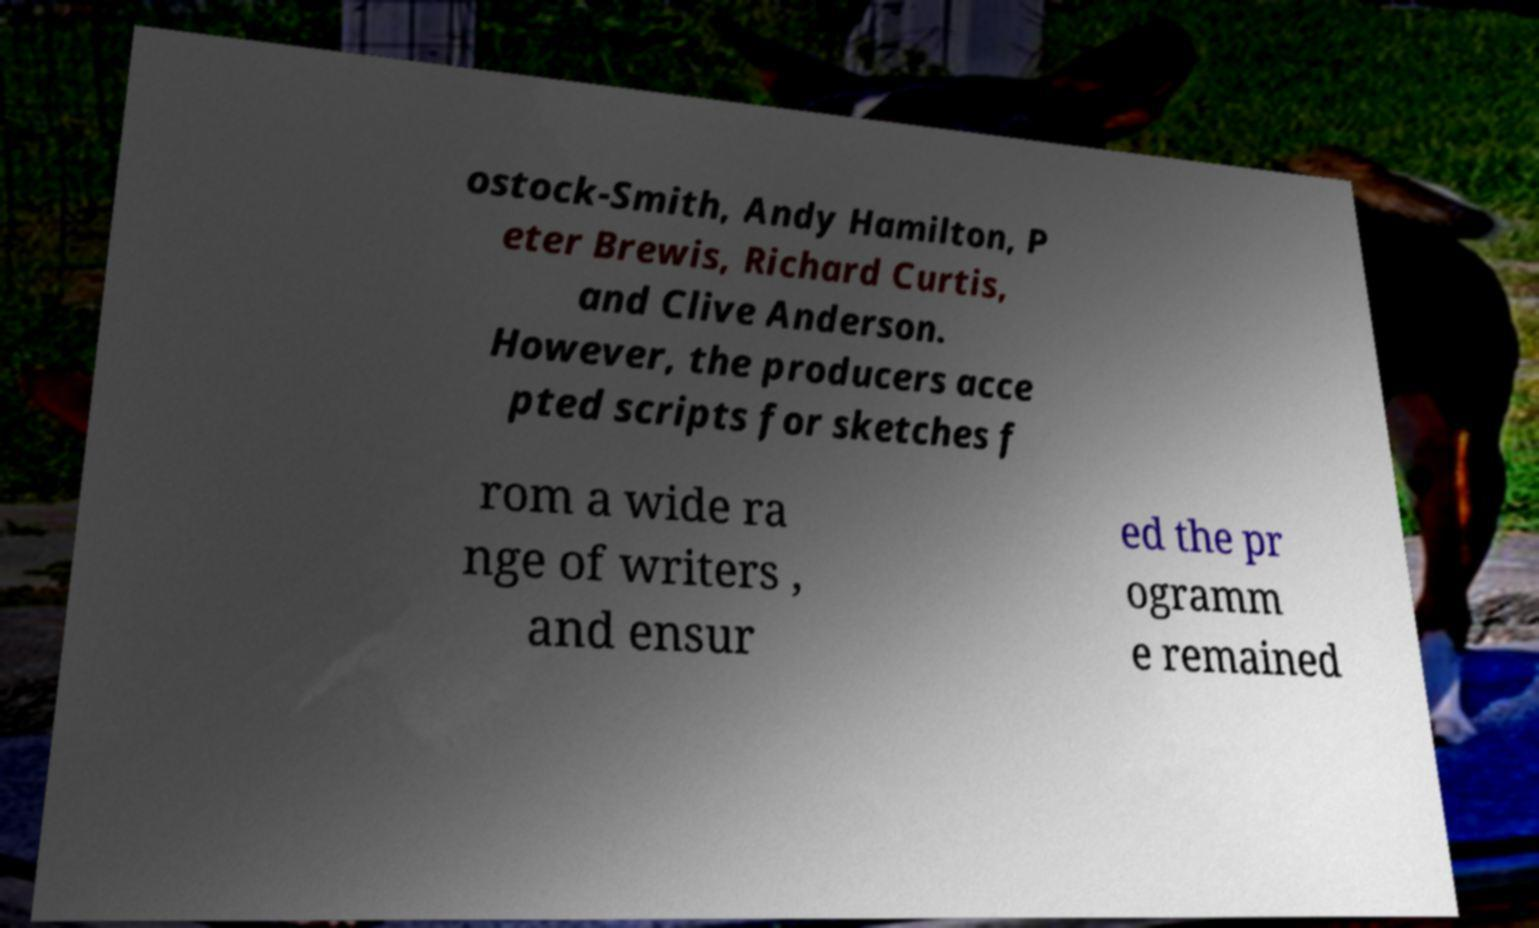Can you read and provide the text displayed in the image?This photo seems to have some interesting text. Can you extract and type it out for me? ostock-Smith, Andy Hamilton, P eter Brewis, Richard Curtis, and Clive Anderson. However, the producers acce pted scripts for sketches f rom a wide ra nge of writers , and ensur ed the pr ogramm e remained 